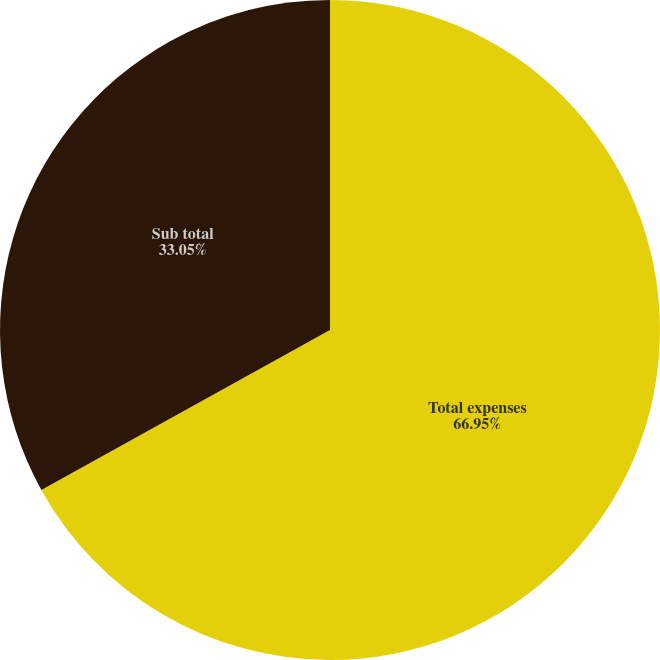<chart> <loc_0><loc_0><loc_500><loc_500><pie_chart><fcel>Total expenses<fcel>Sub total<nl><fcel>66.95%<fcel>33.05%<nl></chart> 